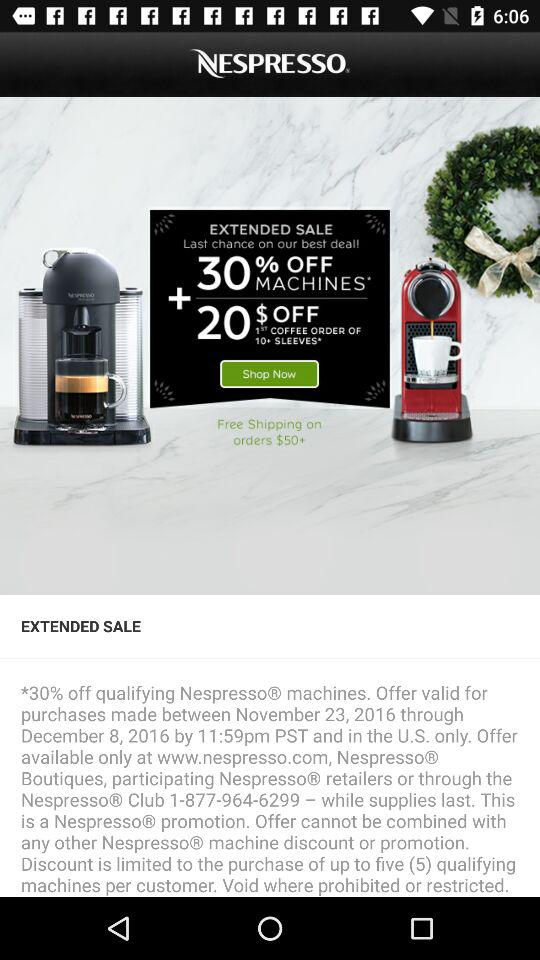How many percent off is the sale?
Answer the question using a single word or phrase. 30% 